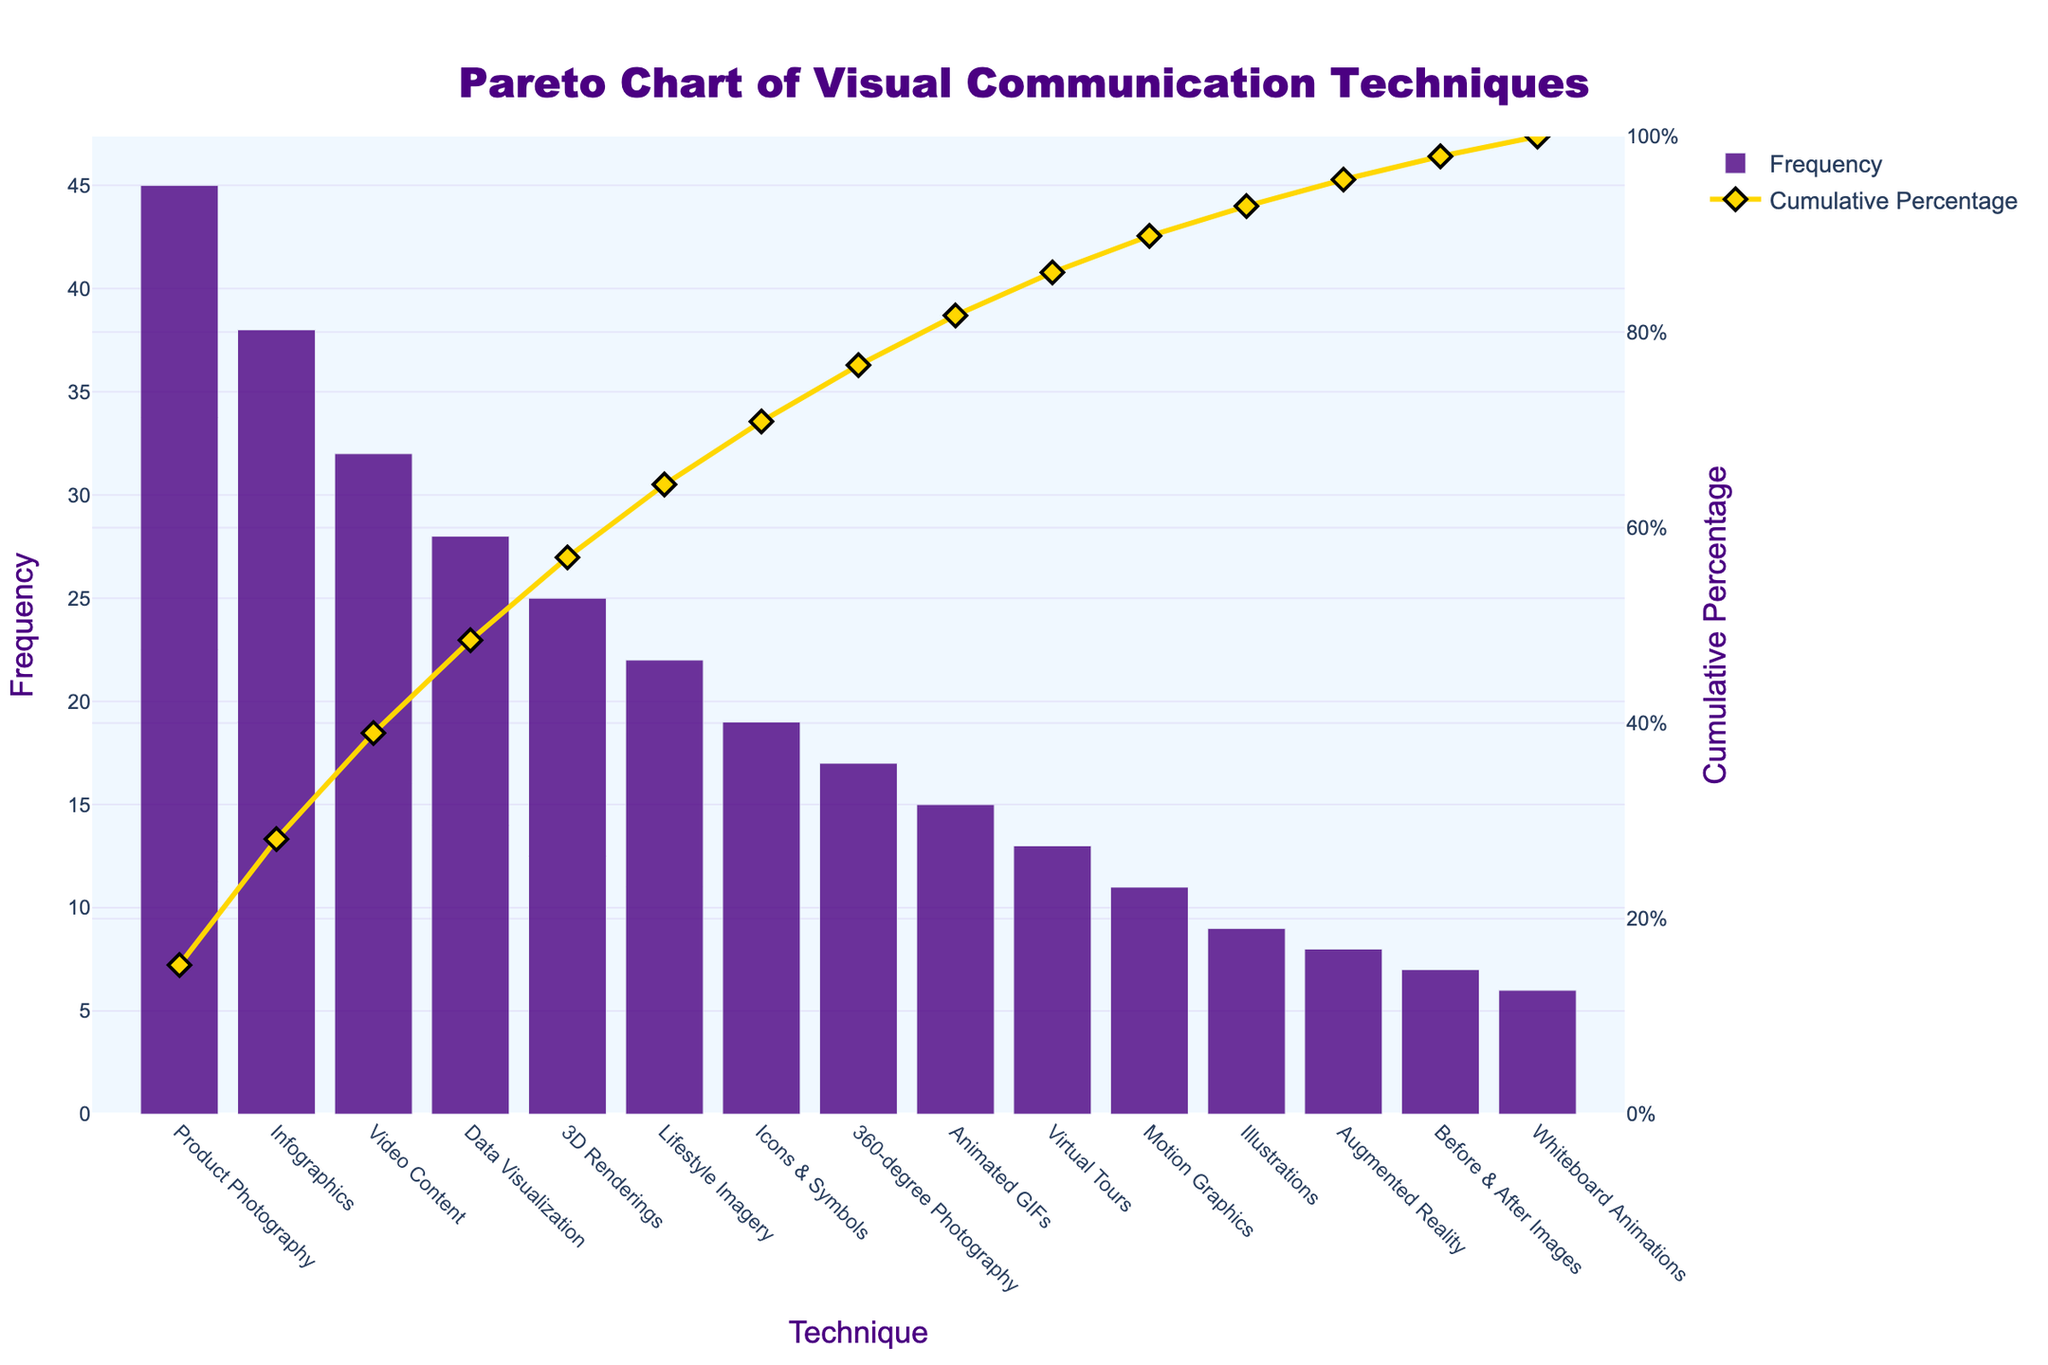What's the title of the figure? The title of the figure is placed at the top center and reads "Pareto Chart of Visual Communication Techniques". Titles of charts are typically located above the graph to provide an immediate context for the viewer.
Answer: Pareto Chart of Visual Communication Techniques Which technique has the highest frequency? The technique with the highest bar is "Product Photography" in the "Frequency" bar chart, indicating it has the highest frequency. The height of the bar represents the frequency count.
Answer: Product Photography What's the cumulative percentage when 3D Renderings are reached? To find the cumulative percentage for "3D Renderings", observe the y-axis on the right marked "Cumulative Percentage". The line corresponding to "3D Renderings" has a value close to the 60% mark.
Answer: ~60% Which techniques contribute to reaching just over 50% cumulative percentage? To find the techniques contributing to just over 50% cumulative percentage, look at the cumulative percentage line and observe the corresponding techniques. It appears that "Product Photography," "Infographics," and "Video Content" together make up just over 50%.
Answer: Product Photography, Infographics, Video Content What is the frequency difference between the highest and lowest frequency techniques? The highest frequency technique is "Product Photography" at 45, and the lowest is "Whiteboard Animations" at 6. Subtracting the lowest from the highest gives 45 - 6 = 39.
Answer: 39 How many techniques have a frequency above 20? Count the bars that extend above the frequency mark of 20. "Product Photography," "Infographics," "Video Content," "Data Visualization," and "3D Renderings" all have frequencies above 20. There are 5 such techniques.
Answer: 5 Which technique corresponds to a cumulative percentage of approximately 80%? To find this, look along the cumulative percentage y-axis that shows 80%, then identify the corresponding technique along the x-axis. This point roughly aligns with "Icons & Symbols".
Answer: Icons & Symbols How are the x-axis ticks labeled? The x-axis represents the different techniques used in visual communication, with each label rotated at an angle for better readability. The labels include: "Product Photography", "Infographics", "Video Content", amongst others.
Answer: Techniques, rotated What does the right y-axis represent in the figure? The right y-axis represents the "Cumulative Percentage", indicating the running total percentage of the frequencies as one moves from the most frequent to the least frequent techniques.
Answer: Cumulative Percentage 